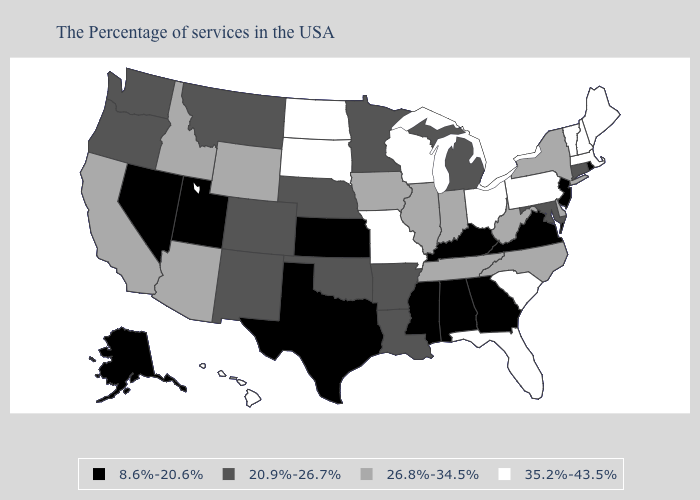Is the legend a continuous bar?
Short answer required. No. Among the states that border Indiana , does Illinois have the highest value?
Short answer required. No. Name the states that have a value in the range 8.6%-20.6%?
Keep it brief. Rhode Island, New Jersey, Virginia, Georgia, Kentucky, Alabama, Mississippi, Kansas, Texas, Utah, Nevada, Alaska. Which states hav the highest value in the Northeast?
Short answer required. Maine, Massachusetts, New Hampshire, Vermont, Pennsylvania. Does Pennsylvania have the highest value in the USA?
Concise answer only. Yes. What is the value of Wyoming?
Write a very short answer. 26.8%-34.5%. Name the states that have a value in the range 35.2%-43.5%?
Concise answer only. Maine, Massachusetts, New Hampshire, Vermont, Pennsylvania, South Carolina, Ohio, Florida, Wisconsin, Missouri, South Dakota, North Dakota, Hawaii. Among the states that border Texas , which have the highest value?
Concise answer only. Louisiana, Arkansas, Oklahoma, New Mexico. Name the states that have a value in the range 35.2%-43.5%?
Quick response, please. Maine, Massachusetts, New Hampshire, Vermont, Pennsylvania, South Carolina, Ohio, Florida, Wisconsin, Missouri, South Dakota, North Dakota, Hawaii. Does the first symbol in the legend represent the smallest category?
Be succinct. Yes. Name the states that have a value in the range 8.6%-20.6%?
Be succinct. Rhode Island, New Jersey, Virginia, Georgia, Kentucky, Alabama, Mississippi, Kansas, Texas, Utah, Nevada, Alaska. Which states hav the highest value in the MidWest?
Short answer required. Ohio, Wisconsin, Missouri, South Dakota, North Dakota. Name the states that have a value in the range 20.9%-26.7%?
Give a very brief answer. Connecticut, Maryland, Michigan, Louisiana, Arkansas, Minnesota, Nebraska, Oklahoma, Colorado, New Mexico, Montana, Washington, Oregon. What is the lowest value in states that border Washington?
Be succinct. 20.9%-26.7%. What is the value of Connecticut?
Short answer required. 20.9%-26.7%. 